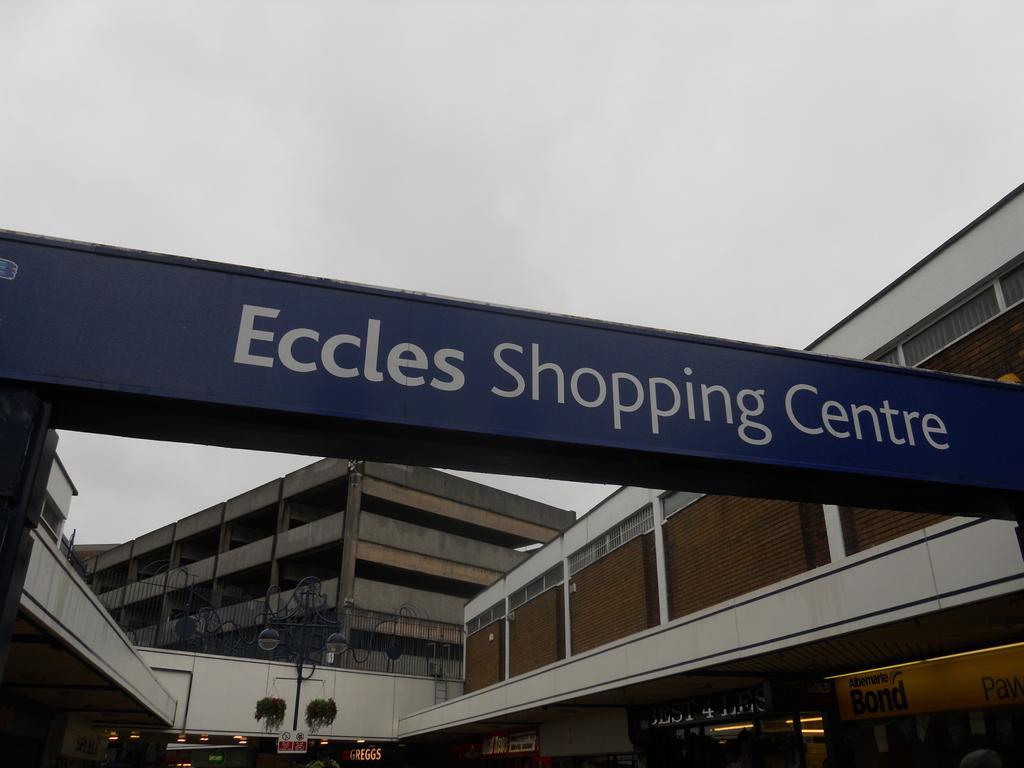In one or two sentences, can you explain what this image depicts? This is the picture of a place where we have some buildings and also a board on which there is something written and also we can see some boards and poles. 